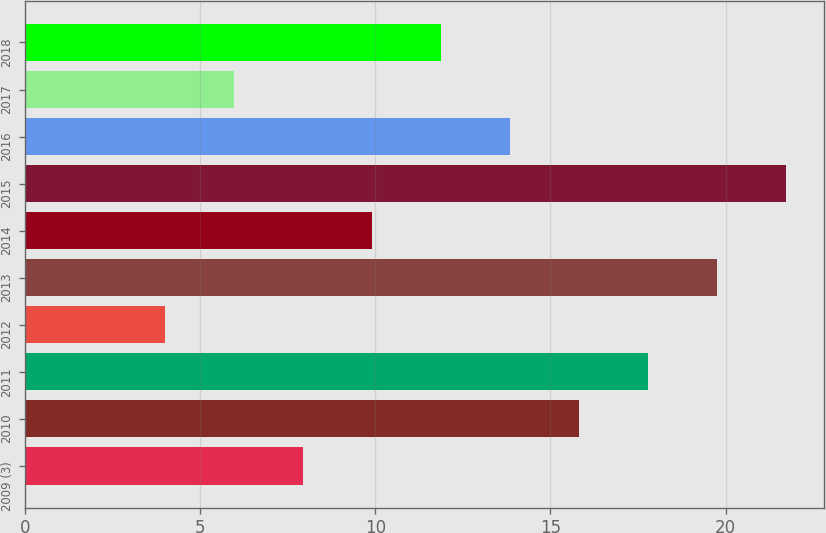Convert chart. <chart><loc_0><loc_0><loc_500><loc_500><bar_chart><fcel>2009 (3)<fcel>2010<fcel>2011<fcel>2012<fcel>2013<fcel>2014<fcel>2015<fcel>2016<fcel>2017<fcel>2018<nl><fcel>7.94<fcel>15.82<fcel>17.79<fcel>4<fcel>19.76<fcel>9.91<fcel>21.73<fcel>13.85<fcel>5.97<fcel>11.88<nl></chart> 